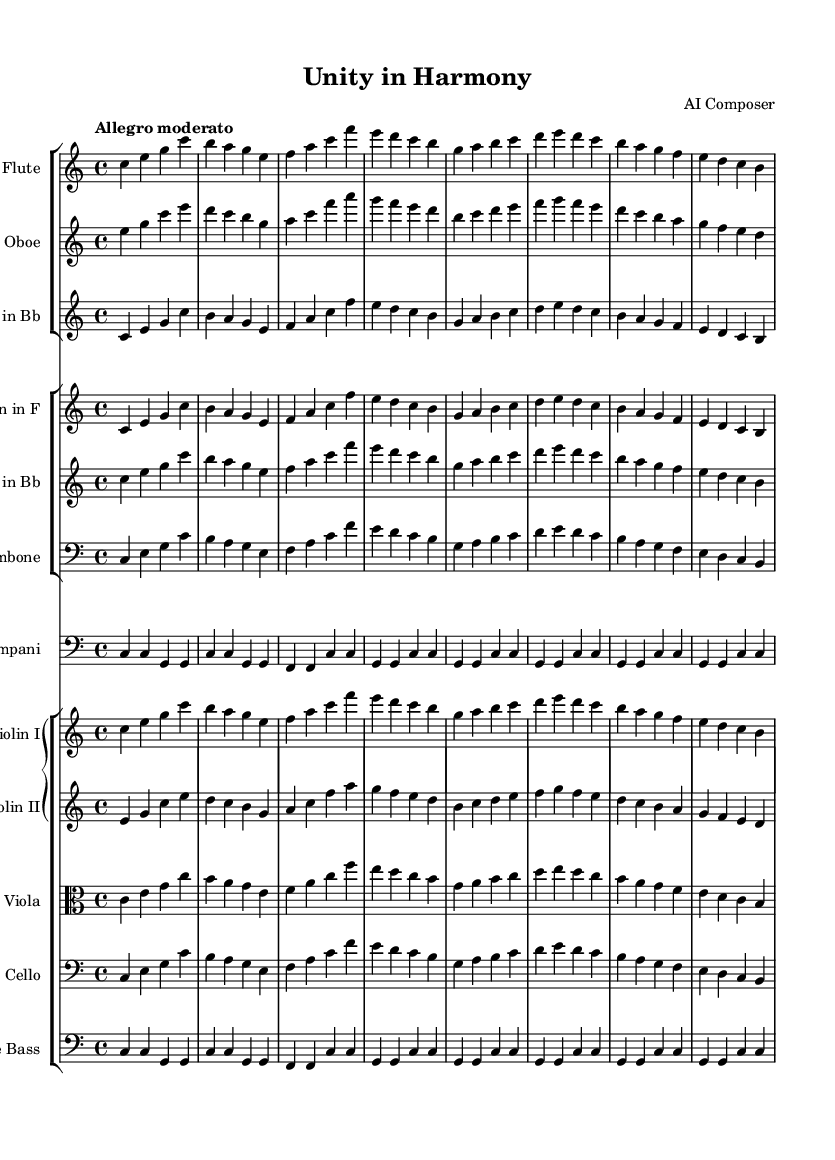What is the key signature of this music? The key signature is indicated at the beginning of the score, which shows no sharps or flats, identifying it as C major.
Answer: C major What is the time signature? The time signature is found at the start of the score, represented by the numbers 4 and 4, which means there are four beats per measure.
Answer: 4/4 What is the tempo marking for this piece? The tempo is indicated as "Allegro moderato," which suggests a moderately fast pace for the music.
Answer: Allegro moderato How many instruments are in the score? By counting the staff groups and the instruments listed, there are a total of 12 distinct instruments represented in the piece.
Answer: 12 What is the lowest instrument in this piece? The double bass, indicated in the score as the bass clef instrument, produces the lowest pitches.
Answer: Double bass Identify one woodwind instrument in this orchestration. The flute is identified within the woodwind group as its first staff in the score.
Answer: Flute Which brass instrument plays a transposed part in this work? The horn in F is indicated to be transposed, as shown by the notation after its staff name.
Answer: Horn 